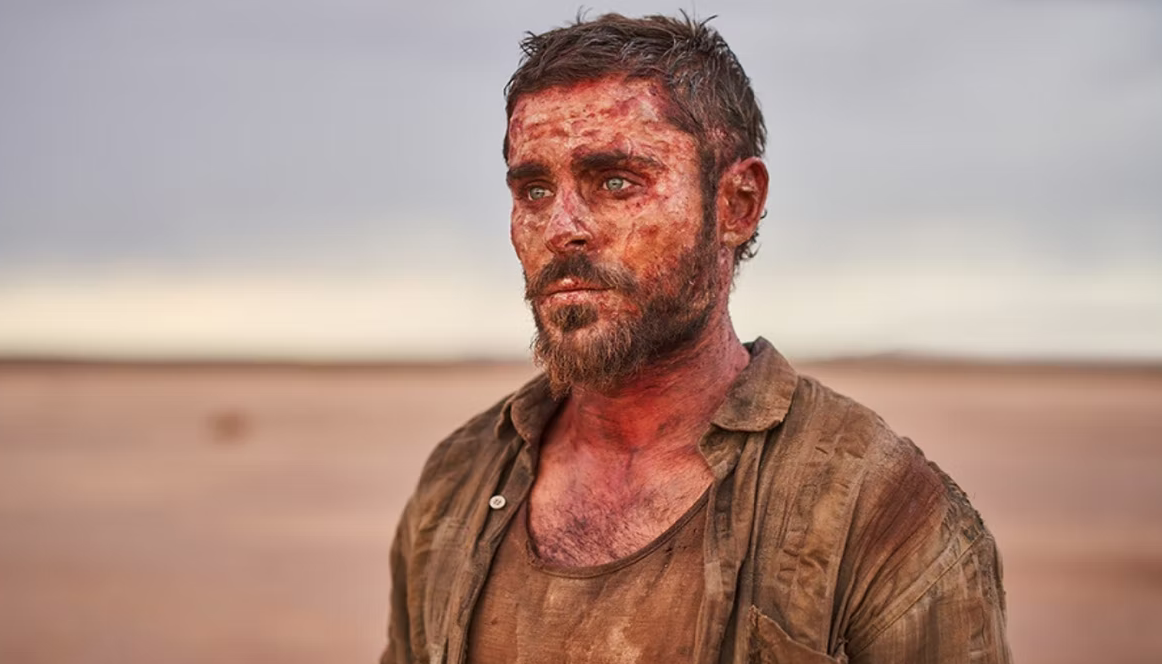Imagine the character is having an internal monologue. What might he be thinking? The character might be thinking: "How did it come to this? I've pushed through every obstacle, yet the horizon seems endless. Every step forward feels like another battle, but I can't give up. I've survived this far - I must find a way out. There's no turning back now, not after everything I've been through. I think of home, of the faces waiting for me, and I know I must keep going. I will emerge from this stronger, I have to believe that." 